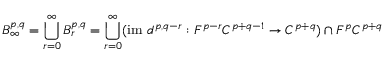<formula> <loc_0><loc_0><loc_500><loc_500>B _ { \infty } ^ { p , q } = \bigcup _ { r = 0 } ^ { \infty } B _ { r } ^ { p , q } = \bigcup _ { r = 0 } ^ { \infty } ( { i m } d ^ { p , q - r } \colon F ^ { p - r } C ^ { p + q - 1 } \rightarrow C ^ { p + q } ) \cap F ^ { p } C ^ { p + q }</formula> 